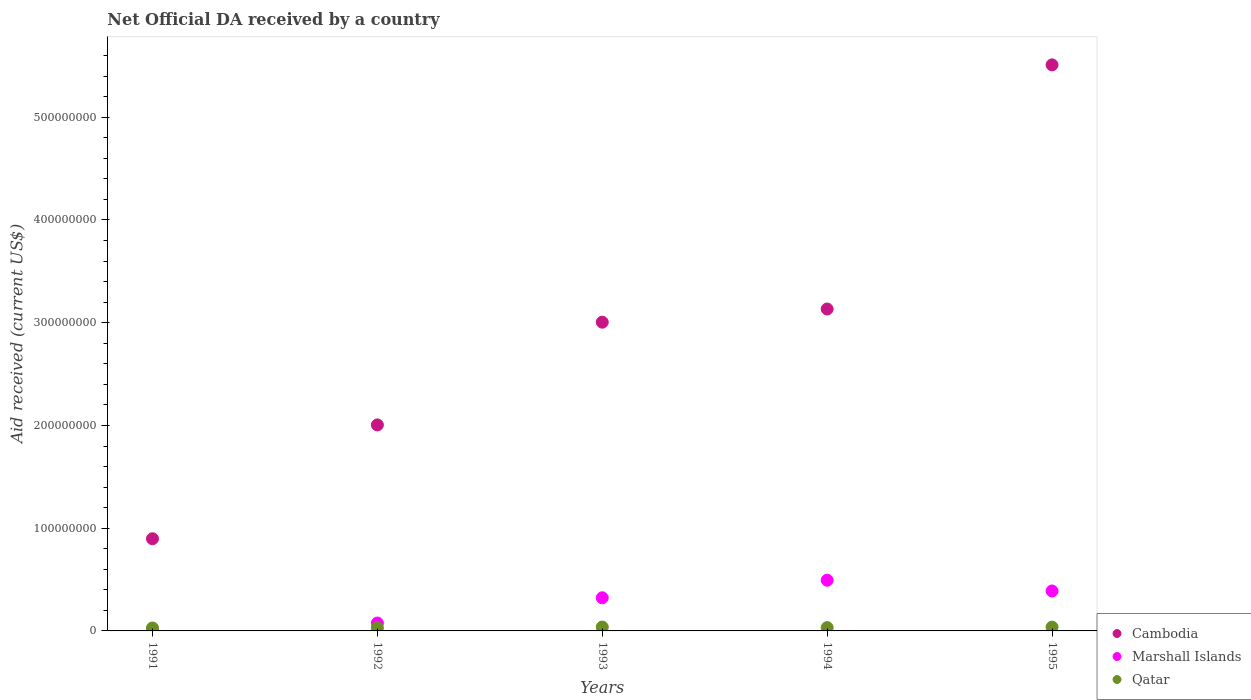How many different coloured dotlines are there?
Ensure brevity in your answer.  3. What is the net official development assistance aid received in Qatar in 1993?
Provide a succinct answer. 3.77e+06. Across all years, what is the maximum net official development assistance aid received in Marshall Islands?
Give a very brief answer. 4.94e+07. Across all years, what is the minimum net official development assistance aid received in Marshall Islands?
Provide a succinct answer. 2.80e+05. In which year was the net official development assistance aid received in Qatar maximum?
Ensure brevity in your answer.  1993. In which year was the net official development assistance aid received in Cambodia minimum?
Ensure brevity in your answer.  1991. What is the total net official development assistance aid received in Marshall Islands in the graph?
Your response must be concise. 1.28e+08. What is the difference between the net official development assistance aid received in Marshall Islands in 1991 and that in 1994?
Offer a very short reply. -4.91e+07. What is the difference between the net official development assistance aid received in Cambodia in 1994 and the net official development assistance aid received in Qatar in 1995?
Your answer should be very brief. 3.10e+08. What is the average net official development assistance aid received in Qatar per year?
Ensure brevity in your answer.  3.31e+06. In the year 1991, what is the difference between the net official development assistance aid received in Marshall Islands and net official development assistance aid received in Qatar?
Your response must be concise. -2.60e+06. What is the ratio of the net official development assistance aid received in Cambodia in 1991 to that in 1994?
Make the answer very short. 0.29. Is the net official development assistance aid received in Cambodia in 1992 less than that in 1993?
Ensure brevity in your answer.  Yes. Is the difference between the net official development assistance aid received in Marshall Islands in 1993 and 1994 greater than the difference between the net official development assistance aid received in Qatar in 1993 and 1994?
Keep it short and to the point. No. What is the difference between the highest and the second highest net official development assistance aid received in Marshall Islands?
Keep it short and to the point. 1.05e+07. What is the difference between the highest and the lowest net official development assistance aid received in Cambodia?
Make the answer very short. 4.61e+08. In how many years, is the net official development assistance aid received in Marshall Islands greater than the average net official development assistance aid received in Marshall Islands taken over all years?
Your answer should be compact. 3. Is the sum of the net official development assistance aid received in Qatar in 1991 and 1994 greater than the maximum net official development assistance aid received in Marshall Islands across all years?
Provide a short and direct response. No. Is the net official development assistance aid received in Marshall Islands strictly less than the net official development assistance aid received in Cambodia over the years?
Your answer should be compact. Yes. How many dotlines are there?
Offer a terse response. 3. How many years are there in the graph?
Your answer should be compact. 5. Does the graph contain any zero values?
Keep it short and to the point. No. What is the title of the graph?
Ensure brevity in your answer.  Net Official DA received by a country. Does "New Zealand" appear as one of the legend labels in the graph?
Make the answer very short. No. What is the label or title of the Y-axis?
Make the answer very short. Aid received (current US$). What is the Aid received (current US$) of Cambodia in 1991?
Keep it short and to the point. 8.97e+07. What is the Aid received (current US$) of Qatar in 1991?
Offer a very short reply. 2.88e+06. What is the Aid received (current US$) of Cambodia in 1992?
Offer a very short reply. 2.01e+08. What is the Aid received (current US$) of Marshall Islands in 1992?
Give a very brief answer. 7.68e+06. What is the Aid received (current US$) of Qatar in 1992?
Provide a succinct answer. 2.92e+06. What is the Aid received (current US$) of Cambodia in 1993?
Make the answer very short. 3.01e+08. What is the Aid received (current US$) of Marshall Islands in 1993?
Your answer should be compact. 3.22e+07. What is the Aid received (current US$) of Qatar in 1993?
Your response must be concise. 3.77e+06. What is the Aid received (current US$) in Cambodia in 1994?
Keep it short and to the point. 3.13e+08. What is the Aid received (current US$) of Marshall Islands in 1994?
Make the answer very short. 4.94e+07. What is the Aid received (current US$) in Qatar in 1994?
Your answer should be compact. 3.22e+06. What is the Aid received (current US$) in Cambodia in 1995?
Offer a terse response. 5.51e+08. What is the Aid received (current US$) in Marshall Islands in 1995?
Make the answer very short. 3.89e+07. What is the Aid received (current US$) in Qatar in 1995?
Your answer should be compact. 3.74e+06. Across all years, what is the maximum Aid received (current US$) in Cambodia?
Your response must be concise. 5.51e+08. Across all years, what is the maximum Aid received (current US$) in Marshall Islands?
Offer a very short reply. 4.94e+07. Across all years, what is the maximum Aid received (current US$) of Qatar?
Offer a very short reply. 3.77e+06. Across all years, what is the minimum Aid received (current US$) in Cambodia?
Provide a short and direct response. 8.97e+07. Across all years, what is the minimum Aid received (current US$) in Marshall Islands?
Offer a very short reply. 2.80e+05. Across all years, what is the minimum Aid received (current US$) of Qatar?
Provide a succinct answer. 2.88e+06. What is the total Aid received (current US$) in Cambodia in the graph?
Offer a very short reply. 1.46e+09. What is the total Aid received (current US$) of Marshall Islands in the graph?
Your answer should be very brief. 1.28e+08. What is the total Aid received (current US$) in Qatar in the graph?
Provide a short and direct response. 1.65e+07. What is the difference between the Aid received (current US$) of Cambodia in 1991 and that in 1992?
Offer a terse response. -1.11e+08. What is the difference between the Aid received (current US$) in Marshall Islands in 1991 and that in 1992?
Your response must be concise. -7.40e+06. What is the difference between the Aid received (current US$) in Cambodia in 1991 and that in 1993?
Provide a succinct answer. -2.11e+08. What is the difference between the Aid received (current US$) of Marshall Islands in 1991 and that in 1993?
Ensure brevity in your answer.  -3.20e+07. What is the difference between the Aid received (current US$) in Qatar in 1991 and that in 1993?
Your response must be concise. -8.90e+05. What is the difference between the Aid received (current US$) of Cambodia in 1991 and that in 1994?
Ensure brevity in your answer.  -2.24e+08. What is the difference between the Aid received (current US$) in Marshall Islands in 1991 and that in 1994?
Offer a terse response. -4.91e+07. What is the difference between the Aid received (current US$) of Cambodia in 1991 and that in 1995?
Keep it short and to the point. -4.61e+08. What is the difference between the Aid received (current US$) of Marshall Islands in 1991 and that in 1995?
Offer a very short reply. -3.86e+07. What is the difference between the Aid received (current US$) of Qatar in 1991 and that in 1995?
Offer a very short reply. -8.60e+05. What is the difference between the Aid received (current US$) in Cambodia in 1992 and that in 1993?
Provide a short and direct response. -1.00e+08. What is the difference between the Aid received (current US$) of Marshall Islands in 1992 and that in 1993?
Make the answer very short. -2.46e+07. What is the difference between the Aid received (current US$) in Qatar in 1992 and that in 1993?
Keep it short and to the point. -8.50e+05. What is the difference between the Aid received (current US$) in Cambodia in 1992 and that in 1994?
Offer a terse response. -1.13e+08. What is the difference between the Aid received (current US$) in Marshall Islands in 1992 and that in 1994?
Offer a terse response. -4.17e+07. What is the difference between the Aid received (current US$) of Cambodia in 1992 and that in 1995?
Make the answer very short. -3.50e+08. What is the difference between the Aid received (current US$) in Marshall Islands in 1992 and that in 1995?
Offer a very short reply. -3.12e+07. What is the difference between the Aid received (current US$) in Qatar in 1992 and that in 1995?
Offer a terse response. -8.20e+05. What is the difference between the Aid received (current US$) in Cambodia in 1993 and that in 1994?
Your response must be concise. -1.28e+07. What is the difference between the Aid received (current US$) of Marshall Islands in 1993 and that in 1994?
Make the answer very short. -1.71e+07. What is the difference between the Aid received (current US$) in Cambodia in 1993 and that in 1995?
Offer a very short reply. -2.50e+08. What is the difference between the Aid received (current US$) in Marshall Islands in 1993 and that in 1995?
Offer a terse response. -6.63e+06. What is the difference between the Aid received (current US$) of Qatar in 1993 and that in 1995?
Provide a short and direct response. 3.00e+04. What is the difference between the Aid received (current US$) of Cambodia in 1994 and that in 1995?
Ensure brevity in your answer.  -2.38e+08. What is the difference between the Aid received (current US$) of Marshall Islands in 1994 and that in 1995?
Ensure brevity in your answer.  1.05e+07. What is the difference between the Aid received (current US$) in Qatar in 1994 and that in 1995?
Your answer should be very brief. -5.20e+05. What is the difference between the Aid received (current US$) in Cambodia in 1991 and the Aid received (current US$) in Marshall Islands in 1992?
Offer a terse response. 8.20e+07. What is the difference between the Aid received (current US$) of Cambodia in 1991 and the Aid received (current US$) of Qatar in 1992?
Offer a very short reply. 8.68e+07. What is the difference between the Aid received (current US$) in Marshall Islands in 1991 and the Aid received (current US$) in Qatar in 1992?
Give a very brief answer. -2.64e+06. What is the difference between the Aid received (current US$) of Cambodia in 1991 and the Aid received (current US$) of Marshall Islands in 1993?
Offer a terse response. 5.75e+07. What is the difference between the Aid received (current US$) in Cambodia in 1991 and the Aid received (current US$) in Qatar in 1993?
Ensure brevity in your answer.  8.59e+07. What is the difference between the Aid received (current US$) of Marshall Islands in 1991 and the Aid received (current US$) of Qatar in 1993?
Your response must be concise. -3.49e+06. What is the difference between the Aid received (current US$) of Cambodia in 1991 and the Aid received (current US$) of Marshall Islands in 1994?
Provide a succinct answer. 4.04e+07. What is the difference between the Aid received (current US$) of Cambodia in 1991 and the Aid received (current US$) of Qatar in 1994?
Your response must be concise. 8.65e+07. What is the difference between the Aid received (current US$) of Marshall Islands in 1991 and the Aid received (current US$) of Qatar in 1994?
Make the answer very short. -2.94e+06. What is the difference between the Aid received (current US$) of Cambodia in 1991 and the Aid received (current US$) of Marshall Islands in 1995?
Offer a terse response. 5.08e+07. What is the difference between the Aid received (current US$) in Cambodia in 1991 and the Aid received (current US$) in Qatar in 1995?
Make the answer very short. 8.60e+07. What is the difference between the Aid received (current US$) in Marshall Islands in 1991 and the Aid received (current US$) in Qatar in 1995?
Your response must be concise. -3.46e+06. What is the difference between the Aid received (current US$) of Cambodia in 1992 and the Aid received (current US$) of Marshall Islands in 1993?
Provide a short and direct response. 1.68e+08. What is the difference between the Aid received (current US$) in Cambodia in 1992 and the Aid received (current US$) in Qatar in 1993?
Keep it short and to the point. 1.97e+08. What is the difference between the Aid received (current US$) in Marshall Islands in 1992 and the Aid received (current US$) in Qatar in 1993?
Provide a succinct answer. 3.91e+06. What is the difference between the Aid received (current US$) in Cambodia in 1992 and the Aid received (current US$) in Marshall Islands in 1994?
Provide a succinct answer. 1.51e+08. What is the difference between the Aid received (current US$) of Cambodia in 1992 and the Aid received (current US$) of Qatar in 1994?
Provide a succinct answer. 1.97e+08. What is the difference between the Aid received (current US$) of Marshall Islands in 1992 and the Aid received (current US$) of Qatar in 1994?
Offer a very short reply. 4.46e+06. What is the difference between the Aid received (current US$) of Cambodia in 1992 and the Aid received (current US$) of Marshall Islands in 1995?
Offer a terse response. 1.62e+08. What is the difference between the Aid received (current US$) of Cambodia in 1992 and the Aid received (current US$) of Qatar in 1995?
Give a very brief answer. 1.97e+08. What is the difference between the Aid received (current US$) of Marshall Islands in 1992 and the Aid received (current US$) of Qatar in 1995?
Give a very brief answer. 3.94e+06. What is the difference between the Aid received (current US$) in Cambodia in 1993 and the Aid received (current US$) in Marshall Islands in 1994?
Keep it short and to the point. 2.51e+08. What is the difference between the Aid received (current US$) in Cambodia in 1993 and the Aid received (current US$) in Qatar in 1994?
Offer a terse response. 2.97e+08. What is the difference between the Aid received (current US$) of Marshall Islands in 1993 and the Aid received (current US$) of Qatar in 1994?
Provide a succinct answer. 2.90e+07. What is the difference between the Aid received (current US$) in Cambodia in 1993 and the Aid received (current US$) in Marshall Islands in 1995?
Offer a very short reply. 2.62e+08. What is the difference between the Aid received (current US$) of Cambodia in 1993 and the Aid received (current US$) of Qatar in 1995?
Keep it short and to the point. 2.97e+08. What is the difference between the Aid received (current US$) in Marshall Islands in 1993 and the Aid received (current US$) in Qatar in 1995?
Your response must be concise. 2.85e+07. What is the difference between the Aid received (current US$) of Cambodia in 1994 and the Aid received (current US$) of Marshall Islands in 1995?
Provide a succinct answer. 2.74e+08. What is the difference between the Aid received (current US$) in Cambodia in 1994 and the Aid received (current US$) in Qatar in 1995?
Offer a terse response. 3.10e+08. What is the difference between the Aid received (current US$) of Marshall Islands in 1994 and the Aid received (current US$) of Qatar in 1995?
Give a very brief answer. 4.56e+07. What is the average Aid received (current US$) in Cambodia per year?
Offer a terse response. 2.91e+08. What is the average Aid received (current US$) of Marshall Islands per year?
Your answer should be very brief. 2.57e+07. What is the average Aid received (current US$) of Qatar per year?
Your answer should be very brief. 3.31e+06. In the year 1991, what is the difference between the Aid received (current US$) of Cambodia and Aid received (current US$) of Marshall Islands?
Offer a terse response. 8.94e+07. In the year 1991, what is the difference between the Aid received (current US$) in Cambodia and Aid received (current US$) in Qatar?
Offer a terse response. 8.68e+07. In the year 1991, what is the difference between the Aid received (current US$) in Marshall Islands and Aid received (current US$) in Qatar?
Offer a terse response. -2.60e+06. In the year 1992, what is the difference between the Aid received (current US$) of Cambodia and Aid received (current US$) of Marshall Islands?
Ensure brevity in your answer.  1.93e+08. In the year 1992, what is the difference between the Aid received (current US$) of Cambodia and Aid received (current US$) of Qatar?
Ensure brevity in your answer.  1.98e+08. In the year 1992, what is the difference between the Aid received (current US$) of Marshall Islands and Aid received (current US$) of Qatar?
Provide a succinct answer. 4.76e+06. In the year 1993, what is the difference between the Aid received (current US$) of Cambodia and Aid received (current US$) of Marshall Islands?
Keep it short and to the point. 2.68e+08. In the year 1993, what is the difference between the Aid received (current US$) in Cambodia and Aid received (current US$) in Qatar?
Keep it short and to the point. 2.97e+08. In the year 1993, what is the difference between the Aid received (current US$) in Marshall Islands and Aid received (current US$) in Qatar?
Offer a very short reply. 2.85e+07. In the year 1994, what is the difference between the Aid received (current US$) in Cambodia and Aid received (current US$) in Marshall Islands?
Give a very brief answer. 2.64e+08. In the year 1994, what is the difference between the Aid received (current US$) in Cambodia and Aid received (current US$) in Qatar?
Provide a short and direct response. 3.10e+08. In the year 1994, what is the difference between the Aid received (current US$) of Marshall Islands and Aid received (current US$) of Qatar?
Provide a succinct answer. 4.61e+07. In the year 1995, what is the difference between the Aid received (current US$) in Cambodia and Aid received (current US$) in Marshall Islands?
Your answer should be very brief. 5.12e+08. In the year 1995, what is the difference between the Aid received (current US$) in Cambodia and Aid received (current US$) in Qatar?
Offer a terse response. 5.47e+08. In the year 1995, what is the difference between the Aid received (current US$) in Marshall Islands and Aid received (current US$) in Qatar?
Your answer should be very brief. 3.51e+07. What is the ratio of the Aid received (current US$) in Cambodia in 1991 to that in 1992?
Provide a short and direct response. 0.45. What is the ratio of the Aid received (current US$) in Marshall Islands in 1991 to that in 1992?
Your answer should be very brief. 0.04. What is the ratio of the Aid received (current US$) in Qatar in 1991 to that in 1992?
Keep it short and to the point. 0.99. What is the ratio of the Aid received (current US$) of Cambodia in 1991 to that in 1993?
Offer a terse response. 0.3. What is the ratio of the Aid received (current US$) in Marshall Islands in 1991 to that in 1993?
Provide a short and direct response. 0.01. What is the ratio of the Aid received (current US$) of Qatar in 1991 to that in 1993?
Offer a very short reply. 0.76. What is the ratio of the Aid received (current US$) in Cambodia in 1991 to that in 1994?
Offer a terse response. 0.29. What is the ratio of the Aid received (current US$) in Marshall Islands in 1991 to that in 1994?
Your answer should be compact. 0.01. What is the ratio of the Aid received (current US$) of Qatar in 1991 to that in 1994?
Your answer should be compact. 0.89. What is the ratio of the Aid received (current US$) in Cambodia in 1991 to that in 1995?
Your answer should be compact. 0.16. What is the ratio of the Aid received (current US$) of Marshall Islands in 1991 to that in 1995?
Your answer should be compact. 0.01. What is the ratio of the Aid received (current US$) of Qatar in 1991 to that in 1995?
Your answer should be compact. 0.77. What is the ratio of the Aid received (current US$) in Cambodia in 1992 to that in 1993?
Provide a short and direct response. 0.67. What is the ratio of the Aid received (current US$) of Marshall Islands in 1992 to that in 1993?
Give a very brief answer. 0.24. What is the ratio of the Aid received (current US$) in Qatar in 1992 to that in 1993?
Ensure brevity in your answer.  0.77. What is the ratio of the Aid received (current US$) of Cambodia in 1992 to that in 1994?
Provide a short and direct response. 0.64. What is the ratio of the Aid received (current US$) of Marshall Islands in 1992 to that in 1994?
Provide a succinct answer. 0.16. What is the ratio of the Aid received (current US$) in Qatar in 1992 to that in 1994?
Provide a short and direct response. 0.91. What is the ratio of the Aid received (current US$) in Cambodia in 1992 to that in 1995?
Give a very brief answer. 0.36. What is the ratio of the Aid received (current US$) of Marshall Islands in 1992 to that in 1995?
Your response must be concise. 0.2. What is the ratio of the Aid received (current US$) of Qatar in 1992 to that in 1995?
Give a very brief answer. 0.78. What is the ratio of the Aid received (current US$) of Cambodia in 1993 to that in 1994?
Offer a terse response. 0.96. What is the ratio of the Aid received (current US$) of Marshall Islands in 1993 to that in 1994?
Offer a terse response. 0.65. What is the ratio of the Aid received (current US$) of Qatar in 1993 to that in 1994?
Offer a terse response. 1.17. What is the ratio of the Aid received (current US$) of Cambodia in 1993 to that in 1995?
Give a very brief answer. 0.55. What is the ratio of the Aid received (current US$) of Marshall Islands in 1993 to that in 1995?
Your answer should be compact. 0.83. What is the ratio of the Aid received (current US$) in Cambodia in 1994 to that in 1995?
Provide a succinct answer. 0.57. What is the ratio of the Aid received (current US$) of Marshall Islands in 1994 to that in 1995?
Provide a short and direct response. 1.27. What is the ratio of the Aid received (current US$) in Qatar in 1994 to that in 1995?
Keep it short and to the point. 0.86. What is the difference between the highest and the second highest Aid received (current US$) of Cambodia?
Offer a very short reply. 2.38e+08. What is the difference between the highest and the second highest Aid received (current US$) in Marshall Islands?
Your response must be concise. 1.05e+07. What is the difference between the highest and the second highest Aid received (current US$) of Qatar?
Make the answer very short. 3.00e+04. What is the difference between the highest and the lowest Aid received (current US$) in Cambodia?
Offer a very short reply. 4.61e+08. What is the difference between the highest and the lowest Aid received (current US$) in Marshall Islands?
Your response must be concise. 4.91e+07. What is the difference between the highest and the lowest Aid received (current US$) of Qatar?
Provide a short and direct response. 8.90e+05. 